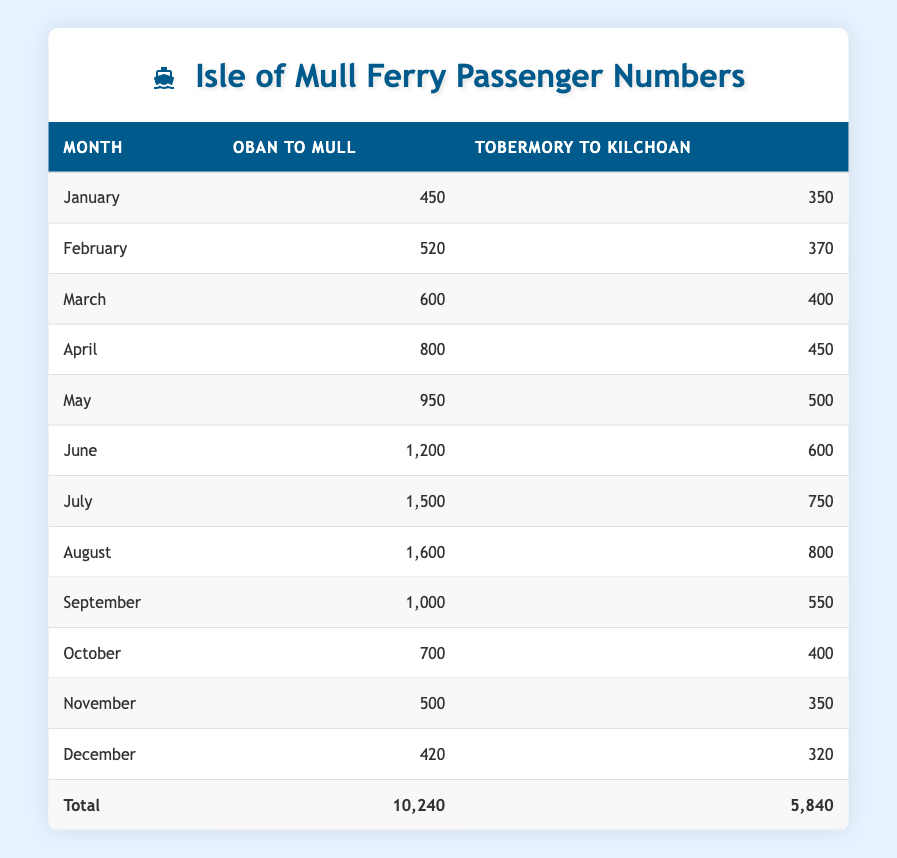What was the total number of passengers for the Oban to Mull route in July? Looking at the table, the number of passengers for the Oban to Mull route in July is explicitly stated as 1500.
Answer: 1500 What is the passenger number for the Tobermory to Kilchoan route in December? According to the table, December's passenger number for the Tobermory to Kilchoan route is listed as 320.
Answer: 320 Which month had the highest passenger count for the Oban to Mull route? The maximum passenger count for the Oban to Mull route is recorded in August with 1600 passengers, as listed in the table.
Answer: 1600 What were the total passenger numbers for both routes combined in the month of April? For April, the passenger count for the Oban to Mull route is 800, and for Tobermory to Kilchoan, it's 450. Adding them together gives us 800 + 450 = 1250.
Answer: 1250 Is it true that more passengers travelled on the Oban to Mull route than the Tobermory to Kilchoan route in June? In June, Oban to Mull had 1200 passengers, while Tobermory to Kilchoan had 600 passengers. Since 1200 is greater than 600, the statement is true.
Answer: Yes What is the average number of passengers for the Tobermory to Kilchoan route throughout the year? Summing all passenger numbers for the Tobermory to Kilchoan route gives us 350 + 370 + 400 + 450 + 500 + 600 + 750 + 800 + 550 + 400 + 350 + 320 = 5840. Dividing this total by 12 months gives an average of 5840/12 = 486.67, which can be approximated to 487.
Answer: 487 In which month did the Oban to Mull route first exceed 1000 passengers? According to the table, the Oban to Mull route exceeded 1000 passengers for the first time in July, where it had 1500 passengers, indicating that it surpassed that threshold in that month.
Answer: July What was the percentage increase in passenger numbers for the Oban to Mull route from January to May? The passenger count went from 450 in January to 950 in May. The increase is 950 - 450 = 500. To find the percentage increase, divide the increase by the original number: (500/450) * 100 = 111.11%, indicating a significant increase in passenger numbers.
Answer: 111.11% 